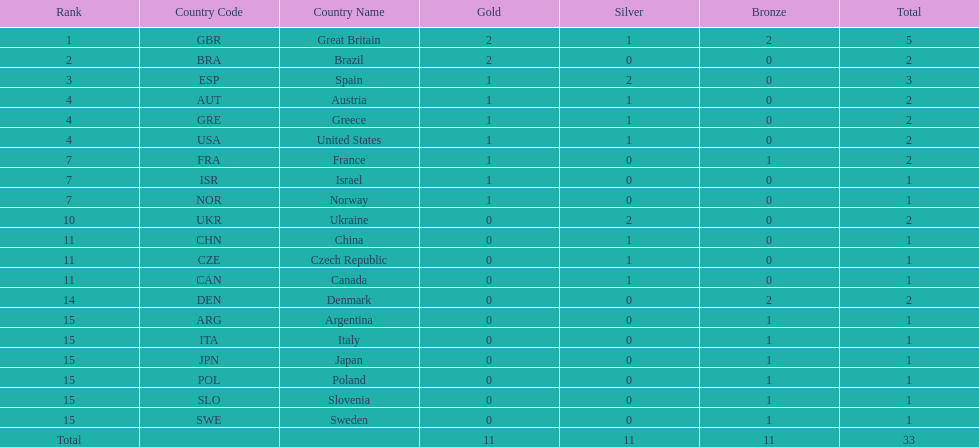Would you mind parsing the complete table? {'header': ['Rank', 'Country Code', 'Country Name', 'Gold', 'Silver', 'Bronze', 'Total'], 'rows': [['1', 'GBR', 'Great Britain', '2', '1', '2', '5'], ['2', 'BRA', 'Brazil', '2', '0', '0', '2'], ['3', 'ESP', 'Spain', '1', '2', '0', '3'], ['4', 'AUT', 'Austria', '1', '1', '0', '2'], ['4', 'GRE', 'Greece', '1', '1', '0', '2'], ['4', 'USA', 'United States', '1', '1', '0', '2'], ['7', 'FRA', 'France', '1', '0', '1', '2'], ['7', 'ISR', 'Israel', '1', '0', '0', '1'], ['7', 'NOR', 'Norway', '1', '0', '0', '1'], ['10', 'UKR', 'Ukraine', '0', '2', '0', '2'], ['11', 'CHN', 'China', '0', '1', '0', '1'], ['11', 'CZE', 'Czech Republic', '0', '1', '0', '1'], ['11', 'CAN', 'Canada', '0', '1', '0', '1'], ['14', 'DEN', 'Denmark', '0', '0', '2', '2'], ['15', 'ARG', 'Argentina', '0', '0', '1', '1'], ['15', 'ITA', 'Italy', '0', '0', '1', '1'], ['15', 'JPN', 'Japan', '0', '0', '1', '1'], ['15', 'POL', 'Poland', '0', '0', '1', '1'], ['15', 'SLO', 'Slovenia', '0', '0', '1', '1'], ['15', 'SWE', 'Sweden', '0', '0', '1', '1'], ['Total', '', '', '11', '11', '11', '33']]} What was the number of silver medals won by ukraine? 2. 